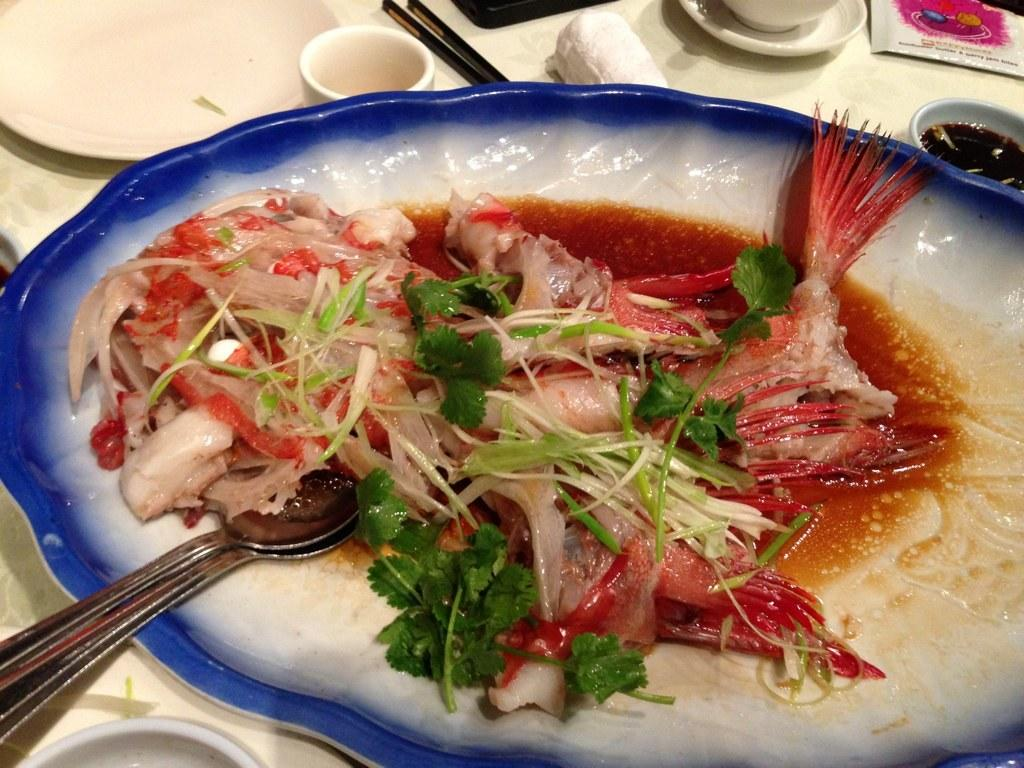What piece of furniture is present in the image? There is a table in the image. What items are placed on the table? There are plates, a cup, a saucer, chopsticks, a spoon, and a dish on the table. Can you describe the dish in the plate? The dish in the plate is not specified in the facts provided. What type of soap is being used to wash the truck in the image? There is no truck or soap present in the image. 